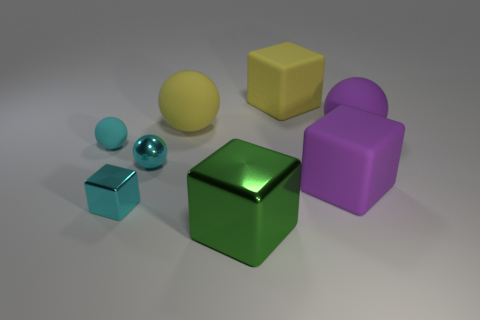Subtract all big blocks. How many blocks are left? 1 Subtract all brown cubes. Subtract all green cylinders. How many cubes are left? 4 Add 1 large cubes. How many objects exist? 9 Add 2 large green metallic things. How many large green metallic things are left? 3 Add 5 large yellow matte objects. How many large yellow matte objects exist? 7 Subtract 1 yellow balls. How many objects are left? 7 Subtract all tiny matte spheres. Subtract all yellow rubber balls. How many objects are left? 6 